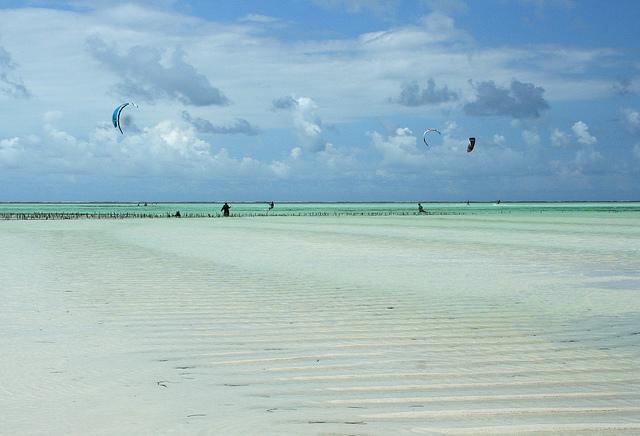Where is this?
Short answer required. Beach. How many kites are there?
Write a very short answer. 3. Where are the kites?
Be succinct. Sky. 